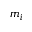Convert formula to latex. <formula><loc_0><loc_0><loc_500><loc_500>m _ { i }</formula> 